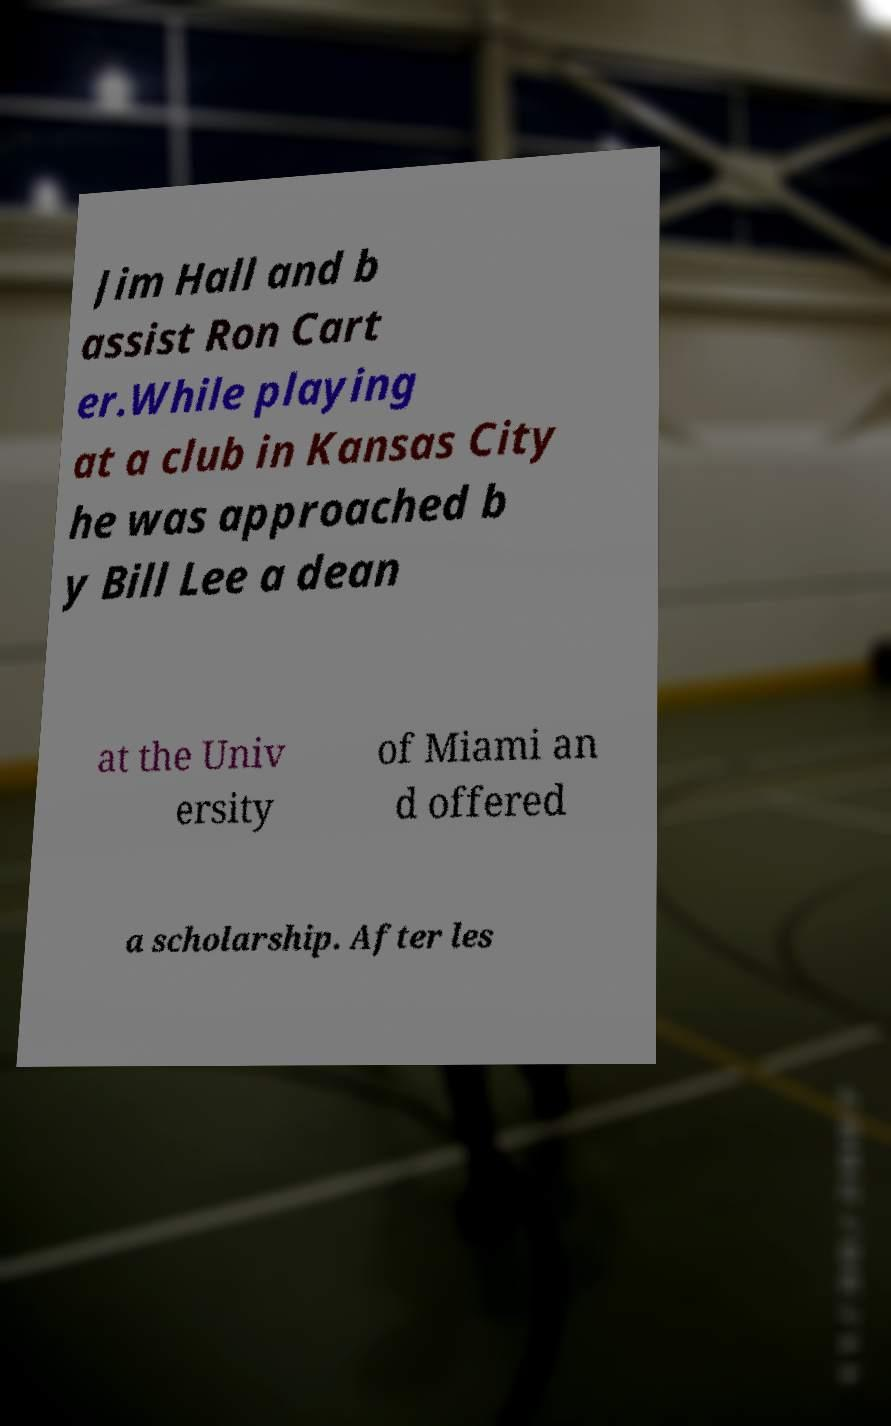Could you assist in decoding the text presented in this image and type it out clearly? Jim Hall and b assist Ron Cart er.While playing at a club in Kansas City he was approached b y Bill Lee a dean at the Univ ersity of Miami an d offered a scholarship. After les 